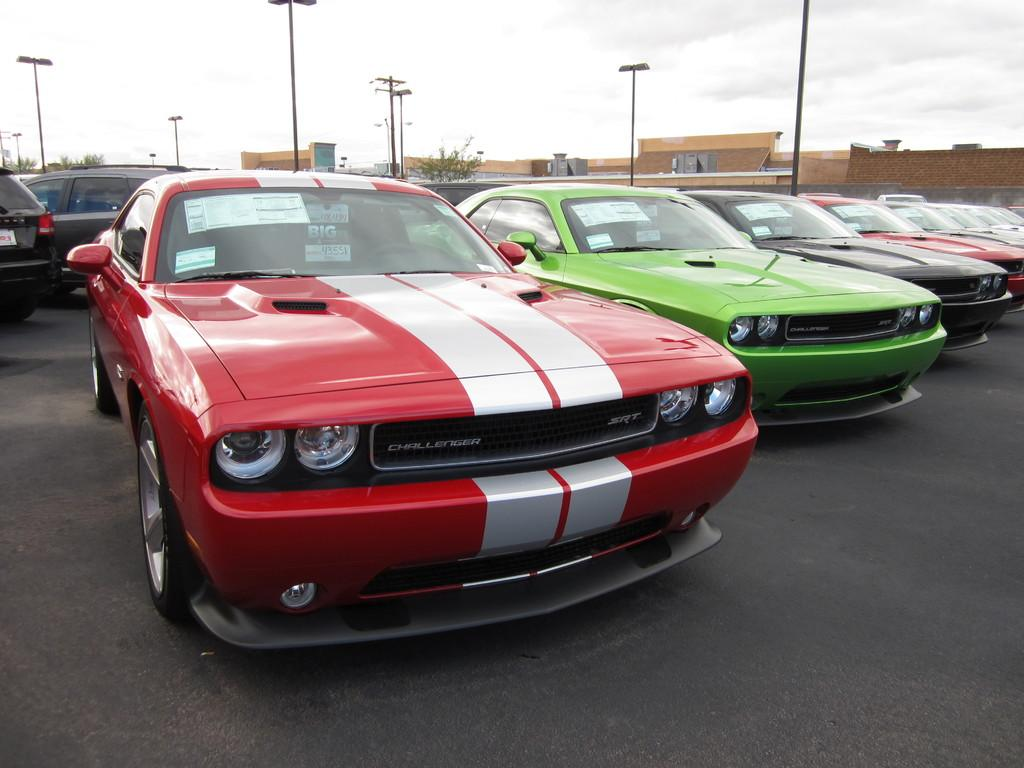What can be seen on the road in the image? There are cars parked on the road in the image. What structures are present along the road? Street poles and street lights are visible in the image. What type of vegetation is present in the image? There are trees in the image. What type of man-made structures can be seen in the image? Buildings are visible in the image. What is visible in the sky in the image? The sky is visible in the image, and clouds are present. What type of lipstick is being advertised on the street pole in the image? There is no lipstick or advertisement present on the street pole in the image. What type of attraction can be seen in the image? There is no specific attraction mentioned or visible in the image; the image shows a street scene with cars, street poles, street lights, trees, buildings, and the sky. 